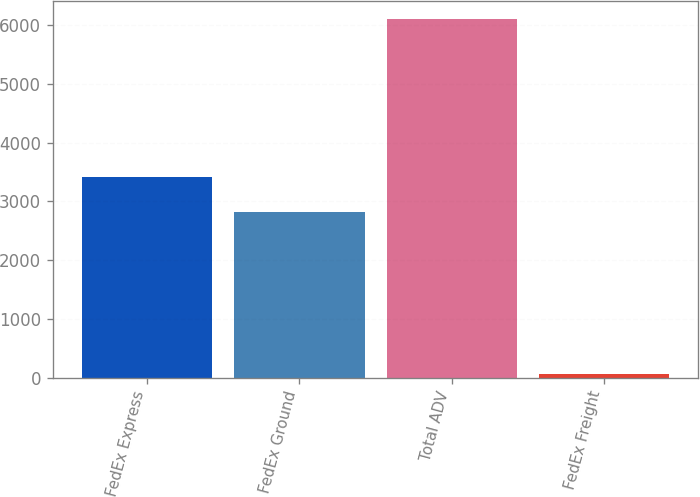<chart> <loc_0><loc_0><loc_500><loc_500><bar_chart><fcel>FedEx Express<fcel>FedEx Ground<fcel>Total ADV<fcel>FedEx Freight<nl><fcel>3418.5<fcel>2815<fcel>6102<fcel>67<nl></chart> 